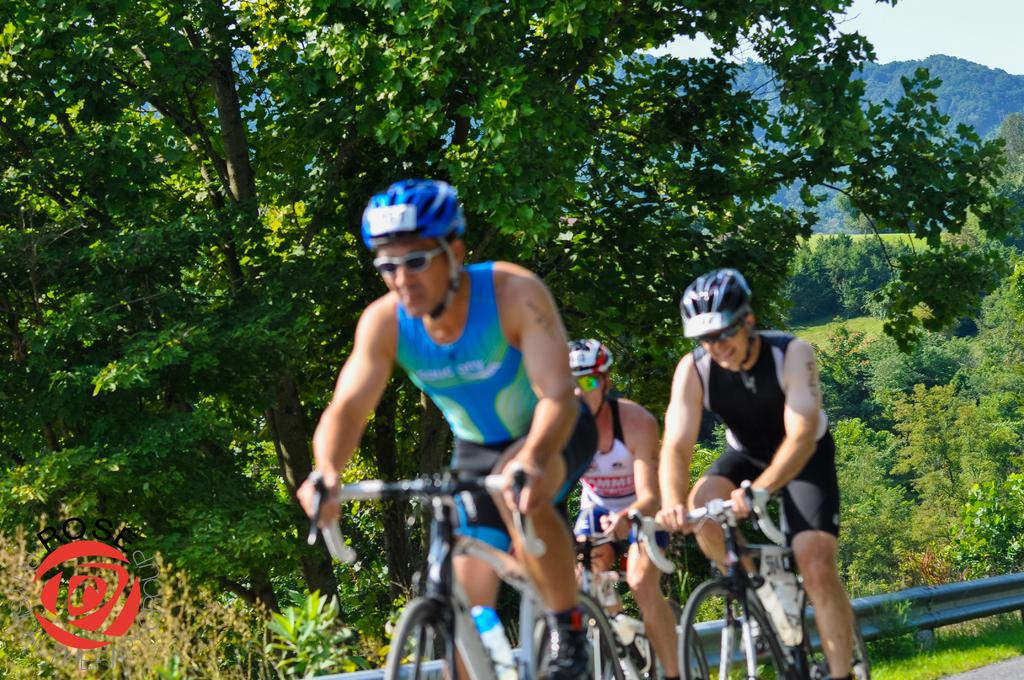How many people are in the image? There are three people in the image. What are the people doing in the image? The people are riding bicycles. What can be seen in the background of the image? There is metal and trees visible in the background of the image. What type of gold territory do the people on the bicycles claim in the image? There is no mention of gold or territory in the image; it simply shows three people riding bicycles with a background of metal and trees. 